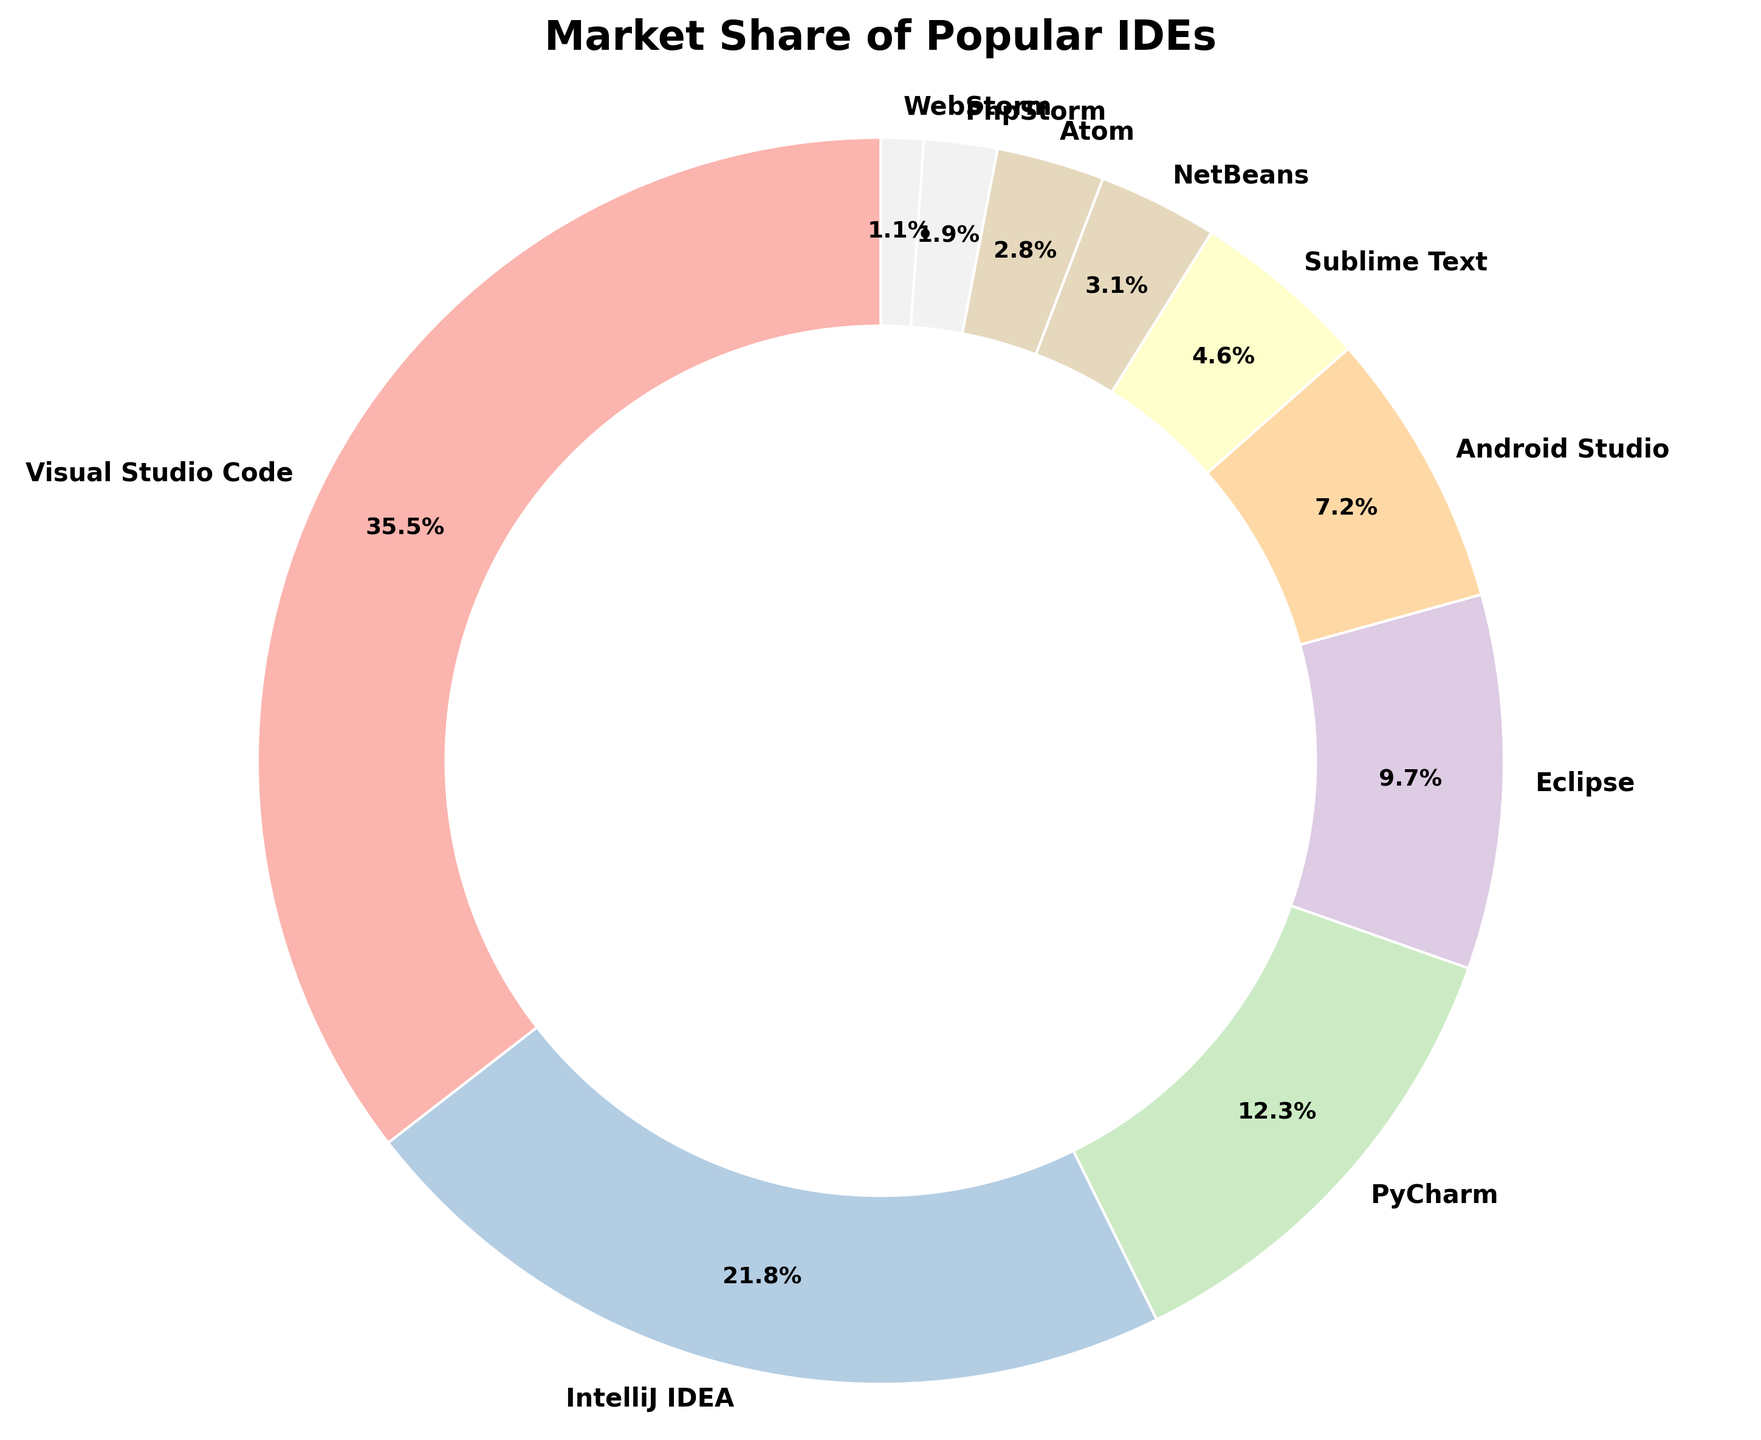What's the combined market share of Visual Studio Code and IntelliJ IDEA? Add the market shares of Visual Studio Code (35.5%) and IntelliJ IDEA (21.8%): 35.5 + 21.8 = 57.3
Answer: 57.3% Which IDE has the smallest market share and what is it? Look at the pie chart to find the smallest segment, which is WebStorm at 1.1%
Answer: WebStorm at 1.1% Is the market share of Eclipse greater than twice the market share of Atom? Calculate twice the market share of Atom: 2.8% * 2 = 5.6%. Then compare this value with the market share of Eclipse, which is 9.7% and it is greater
Answer: Yes, 9.7% > 5.6% What is the total market share of IDEs other than Visual Studio Code and IntelliJ IDEA? Subtract the combined market share of Visual Studio Code and IntelliJ IDEA (57.3%) from 100%: 100 - 57.3 = 42.7
Answer: 42.7% Which color represents Sublime Text and how can you identify it? Identify the segment labeled "Sublime Text" in the pie chart and note its color from the custom color palette
Answer: Light pastel color Compare the market share of PyCharm and Android Studio. See the pie chart or labels to compare the market shares of PyCharm (12.3%) and Android Studio (7.2%) and note that PyCharm has a significantly higher share
Answer: PyCharm > Android Studio What percentage of the market is held by IDEs with a market share of less than 5%? Sum the market shares of Sublime Text (4.6%), NetBeans (3.1%), Atom (2.8%), PhpStorm (1.9%), and WebStorm (1.1%). 4.6 + 3.1 + 2.8 + 1.9 + 1.1 = 13.5
Answer: 13.5% How does the market share of IntelliJ IDEA compare to that of PyCharm and Eclipse combined? Add the market share of PyCharm (12.3%) and Eclipse (9.7%): 12.3 + 9.7 = 22%. Compare it with IntelliJ IDEA's 21.8%
Answer: Close, but the combination is slightly higher What's the difference in market share between Visual Studio Code and the second most popular IDE? Subtract the market share of IntelliJ IDEA (21.8%) from Visual Studio Code (35.5%): 35.5 - 21.8 = 13.7
Answer: 13.7% What's the market share of IDEs starting with the letter 'A'? Android Studio (7.2%) + Atom (2.8%) = 7.2 + 2.8 = 10
Answer: 10% 